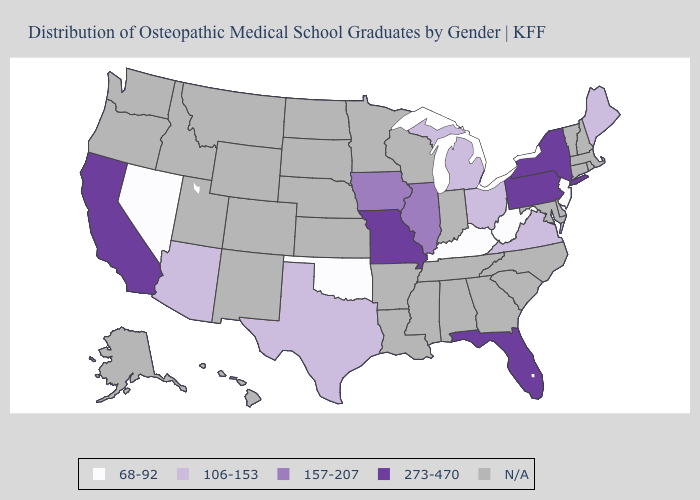Name the states that have a value in the range 157-207?
Quick response, please. Illinois, Iowa. Does West Virginia have the lowest value in the USA?
Short answer required. Yes. Name the states that have a value in the range 157-207?
Quick response, please. Illinois, Iowa. What is the value of Tennessee?
Give a very brief answer. N/A. What is the lowest value in states that border Georgia?
Concise answer only. 273-470. Which states have the lowest value in the USA?
Keep it brief. Kentucky, Nevada, New Jersey, Oklahoma, West Virginia. Name the states that have a value in the range 68-92?
Concise answer only. Kentucky, Nevada, New Jersey, Oklahoma, West Virginia. What is the value of Maryland?
Quick response, please. N/A. Does Iowa have the lowest value in the MidWest?
Give a very brief answer. No. Does Florida have the lowest value in the South?
Concise answer only. No. What is the highest value in the USA?
Be succinct. 273-470. Name the states that have a value in the range N/A?
Keep it brief. Alabama, Alaska, Arkansas, Colorado, Connecticut, Delaware, Georgia, Hawaii, Idaho, Indiana, Kansas, Louisiana, Maryland, Massachusetts, Minnesota, Mississippi, Montana, Nebraska, New Hampshire, New Mexico, North Carolina, North Dakota, Oregon, Rhode Island, South Carolina, South Dakota, Tennessee, Utah, Vermont, Washington, Wisconsin, Wyoming. 